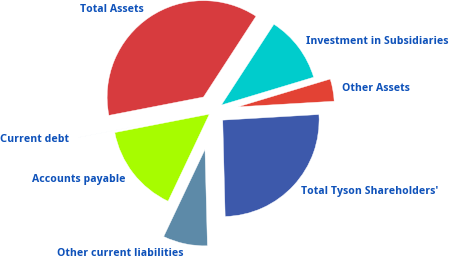Convert chart. <chart><loc_0><loc_0><loc_500><loc_500><pie_chart><fcel>Other Assets<fcel>Investment in Subsidiaries<fcel>Total Assets<fcel>Current debt<fcel>Accounts payable<fcel>Other current liabilities<fcel>Total Tyson Shareholders'<nl><fcel>3.73%<fcel>11.17%<fcel>37.22%<fcel>0.01%<fcel>14.89%<fcel>7.45%<fcel>25.52%<nl></chart> 